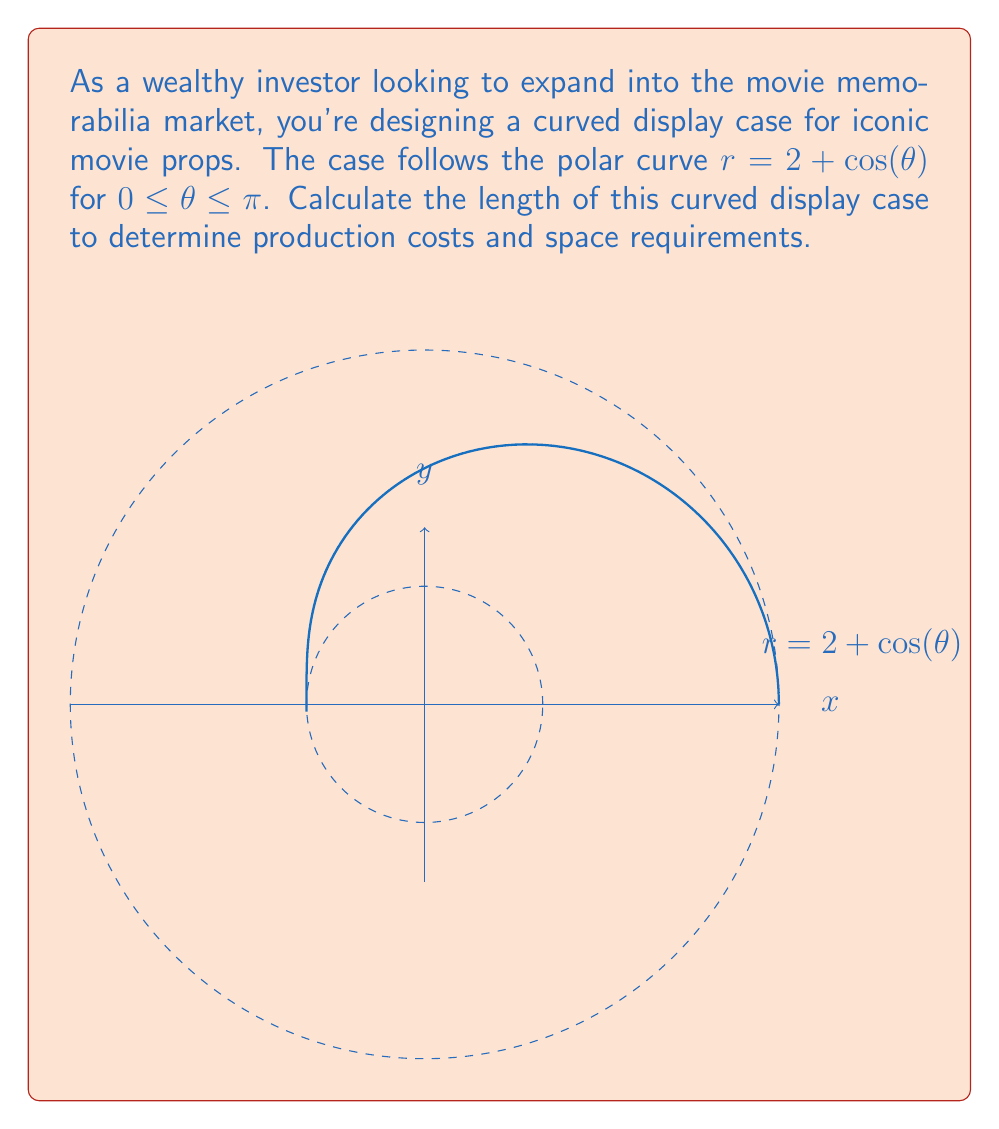Teach me how to tackle this problem. To find the length of the curved display case, we need to use the arc length formula for polar curves:

$$ L = \int_a^b \sqrt{r^2 + \left(\frac{dr}{d\theta}\right)^2} d\theta $$

Step 1: Determine $r$ and $\frac{dr}{d\theta}$
$r = 2 + \cos(\theta)$
$\frac{dr}{d\theta} = -\sin(\theta)$

Step 2: Substitute into the arc length formula
$$ L = \int_0^\pi \sqrt{(2+\cos(\theta))^2 + (-\sin(\theta))^2} d\theta $$

Step 3: Simplify the expression under the square root
$$ L = \int_0^\pi \sqrt{4 + 4\cos(\theta) + \cos^2(\theta) + \sin^2(\theta)} d\theta $$
$$ L = \int_0^\pi \sqrt{5 + 4\cos(\theta)} d\theta $$

Step 4: This integral cannot be solved analytically, so we need to use numerical integration methods. Using a computer algebra system or numerical integration tool, we can evaluate this integral:

$$ L \approx 7.6394 $$

Step 5: Round to two decimal places for practical use in manufacturing and space planning.
Answer: $7.64$ units 